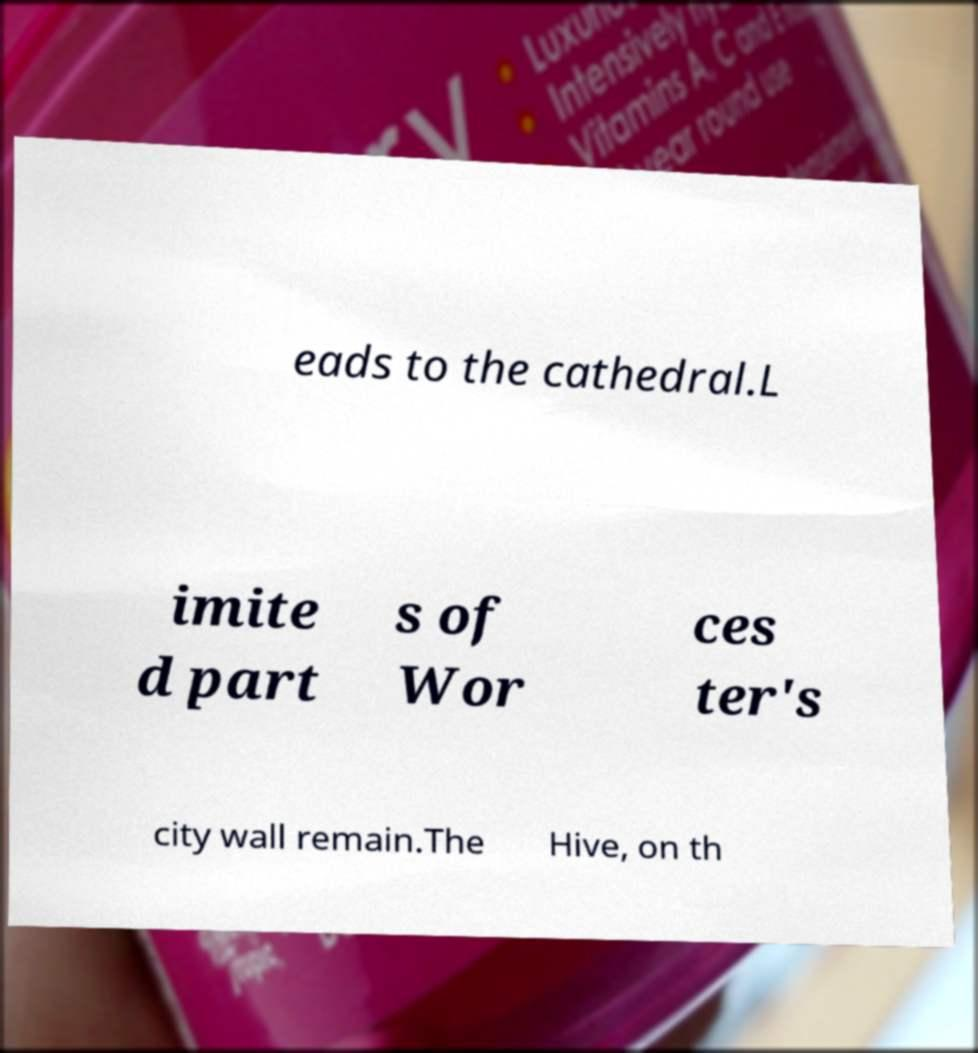There's text embedded in this image that I need extracted. Can you transcribe it verbatim? eads to the cathedral.L imite d part s of Wor ces ter's city wall remain.The Hive, on th 